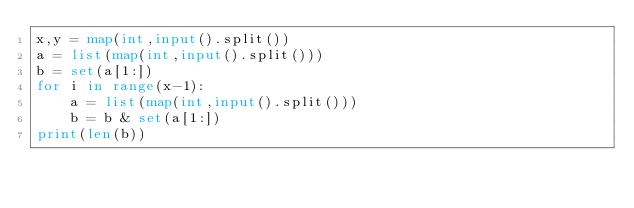Convert code to text. <code><loc_0><loc_0><loc_500><loc_500><_Python_>x,y = map(int,input().split())
a = list(map(int,input().split()))
b = set(a[1:])
for i in range(x-1):
    a = list(map(int,input().split()))
    b = b & set(a[1:])
print(len(b))

</code> 